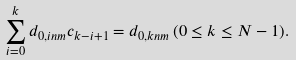<formula> <loc_0><loc_0><loc_500><loc_500>\sum _ { i = 0 } ^ { k } d _ { 0 , i n m } c _ { k - i + 1 } = d _ { 0 , k n m } \, ( 0 \leq k \leq N - 1 ) .</formula> 